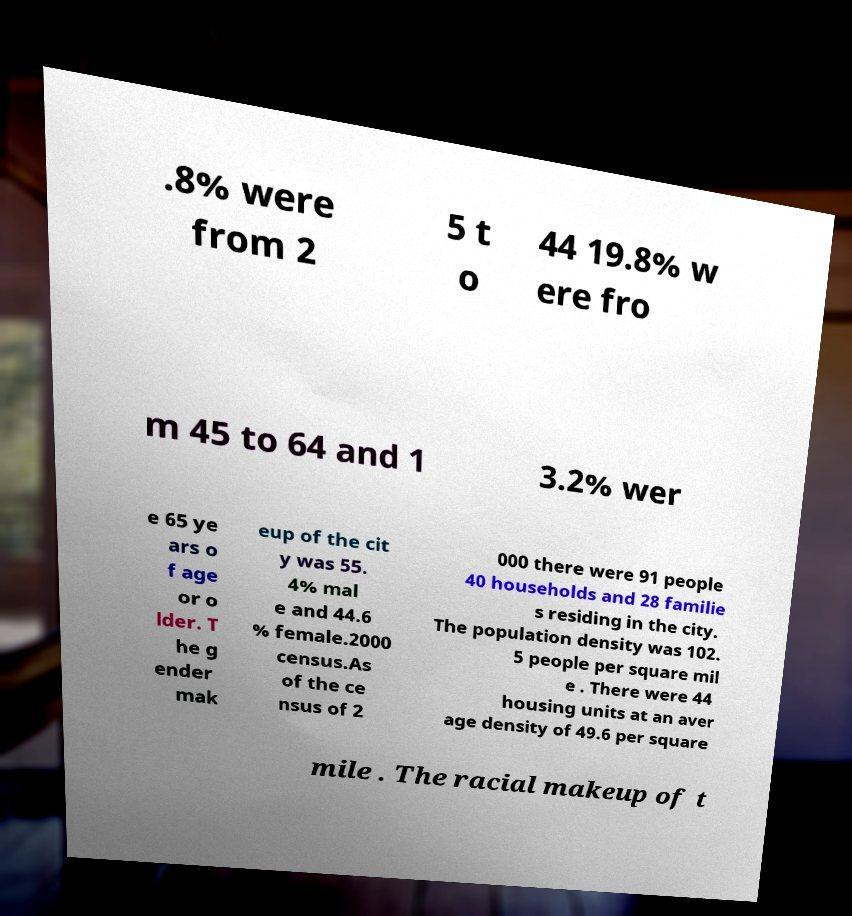Please read and relay the text visible in this image. What does it say? .8% were from 2 5 t o 44 19.8% w ere fro m 45 to 64 and 1 3.2% wer e 65 ye ars o f age or o lder. T he g ender mak eup of the cit y was 55. 4% mal e and 44.6 % female.2000 census.As of the ce nsus of 2 000 there were 91 people 40 households and 28 familie s residing in the city. The population density was 102. 5 people per square mil e . There were 44 housing units at an aver age density of 49.6 per square mile . The racial makeup of t 